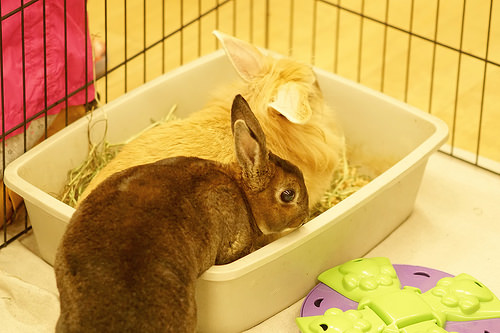<image>
Can you confirm if the eyeball is next to the rabbit? Yes. The eyeball is positioned adjacent to the rabbit, located nearby in the same general area. 